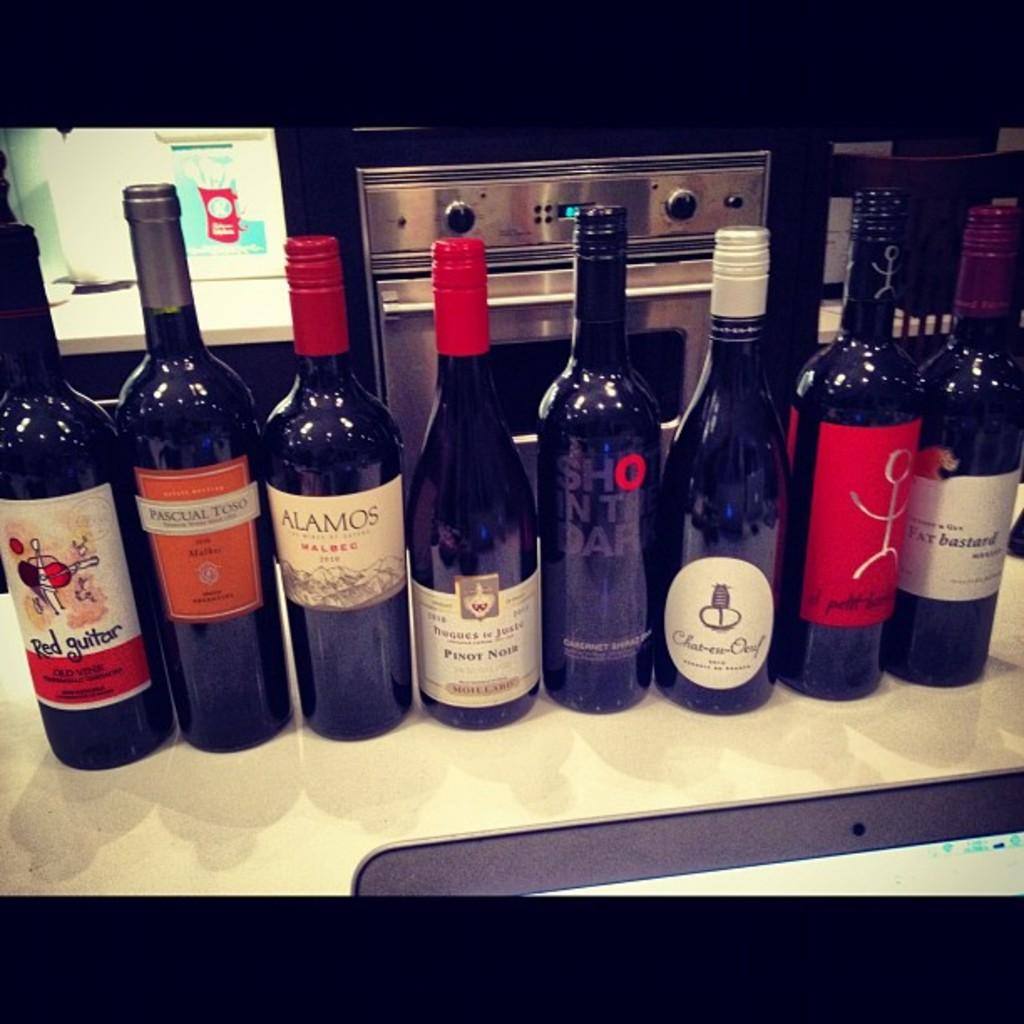<image>
Give a short and clear explanation of the subsequent image. the word alamos that is on a wine bottle 